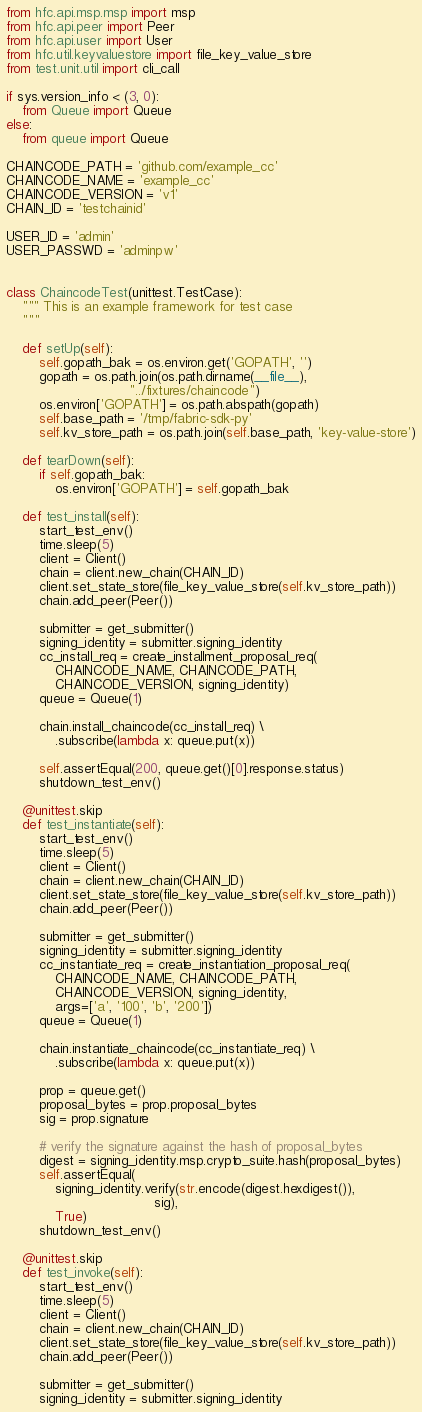Convert code to text. <code><loc_0><loc_0><loc_500><loc_500><_Python_>from hfc.api.msp.msp import msp
from hfc.api.peer import Peer
from hfc.api.user import User
from hfc.util.keyvaluestore import file_key_value_store
from test.unit.util import cli_call

if sys.version_info < (3, 0):
    from Queue import Queue
else:
    from queue import Queue

CHAINCODE_PATH = 'github.com/example_cc'
CHAINCODE_NAME = 'example_cc'
CHAINCODE_VERSION = 'v1'
CHAIN_ID = 'testchainid'

USER_ID = 'admin'
USER_PASSWD = 'adminpw'


class ChaincodeTest(unittest.TestCase):
    """ This is an example framework for test case
    """

    def setUp(self):
        self.gopath_bak = os.environ.get('GOPATH', '')
        gopath = os.path.join(os.path.dirname(__file__),
                              "../fixtures/chaincode")
        os.environ['GOPATH'] = os.path.abspath(gopath)
        self.base_path = '/tmp/fabric-sdk-py'
        self.kv_store_path = os.path.join(self.base_path, 'key-value-store')

    def tearDown(self):
        if self.gopath_bak:
            os.environ['GOPATH'] = self.gopath_bak

    def test_install(self):
        start_test_env()
        time.sleep(5)
        client = Client()
        chain = client.new_chain(CHAIN_ID)
        client.set_state_store(file_key_value_store(self.kv_store_path))
        chain.add_peer(Peer())

        submitter = get_submitter()
        signing_identity = submitter.signing_identity
        cc_install_req = create_installment_proposal_req(
            CHAINCODE_NAME, CHAINCODE_PATH,
            CHAINCODE_VERSION, signing_identity)
        queue = Queue(1)

        chain.install_chaincode(cc_install_req) \
            .subscribe(lambda x: queue.put(x))

        self.assertEqual(200, queue.get()[0].response.status)
        shutdown_test_env()

    @unittest.skip
    def test_instantiate(self):
        start_test_env()
        time.sleep(5)
        client = Client()
        chain = client.new_chain(CHAIN_ID)
        client.set_state_store(file_key_value_store(self.kv_store_path))
        chain.add_peer(Peer())

        submitter = get_submitter()
        signing_identity = submitter.signing_identity
        cc_instantiate_req = create_instantiation_proposal_req(
            CHAINCODE_NAME, CHAINCODE_PATH,
            CHAINCODE_VERSION, signing_identity,
            args=['a', '100', 'b', '200'])
        queue = Queue(1)

        chain.instantiate_chaincode(cc_instantiate_req) \
            .subscribe(lambda x: queue.put(x))

        prop = queue.get()
        proposal_bytes = prop.proposal_bytes
        sig = prop.signature

        # verify the signature against the hash of proposal_bytes
        digest = signing_identity.msp.crypto_suite.hash(proposal_bytes)
        self.assertEqual(
            signing_identity.verify(str.encode(digest.hexdigest()),
                                    sig),
            True)
        shutdown_test_env()

    @unittest.skip
    def test_invoke(self):
        start_test_env()
        time.sleep(5)
        client = Client()
        chain = client.new_chain(CHAIN_ID)
        client.set_state_store(file_key_value_store(self.kv_store_path))
        chain.add_peer(Peer())

        submitter = get_submitter()
        signing_identity = submitter.signing_identity</code> 